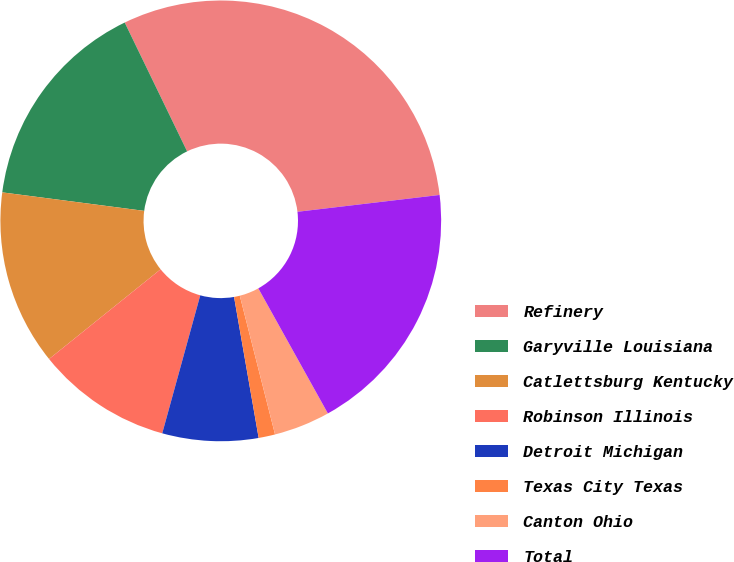Convert chart. <chart><loc_0><loc_0><loc_500><loc_500><pie_chart><fcel>Refinery<fcel>Garyville Louisiana<fcel>Catlettsburg Kentucky<fcel>Robinson Illinois<fcel>Detroit Michigan<fcel>Texas City Texas<fcel>Canton Ohio<fcel>Total<nl><fcel>30.31%<fcel>15.76%<fcel>12.85%<fcel>9.94%<fcel>7.03%<fcel>1.21%<fcel>4.12%<fcel>18.8%<nl></chart> 